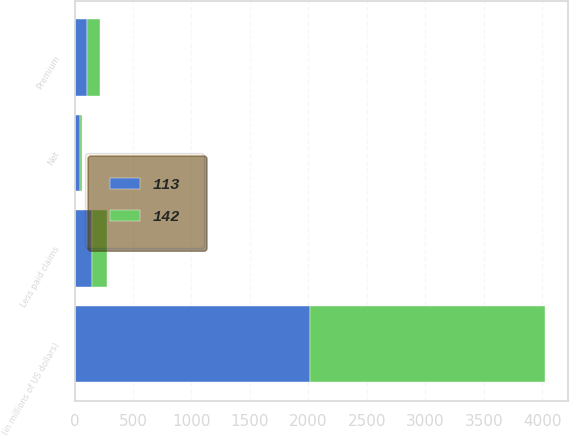Convert chart. <chart><loc_0><loc_0><loc_500><loc_500><stacked_bar_chart><ecel><fcel>(in millions of US dollars)<fcel>Premium<fcel>Less paid claims<fcel>Net<nl><fcel>142<fcel>2010<fcel>109<fcel>125<fcel>16<nl><fcel>113<fcel>2009<fcel>108<fcel>152<fcel>44<nl></chart> 